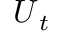Convert formula to latex. <formula><loc_0><loc_0><loc_500><loc_500>U _ { t }</formula> 